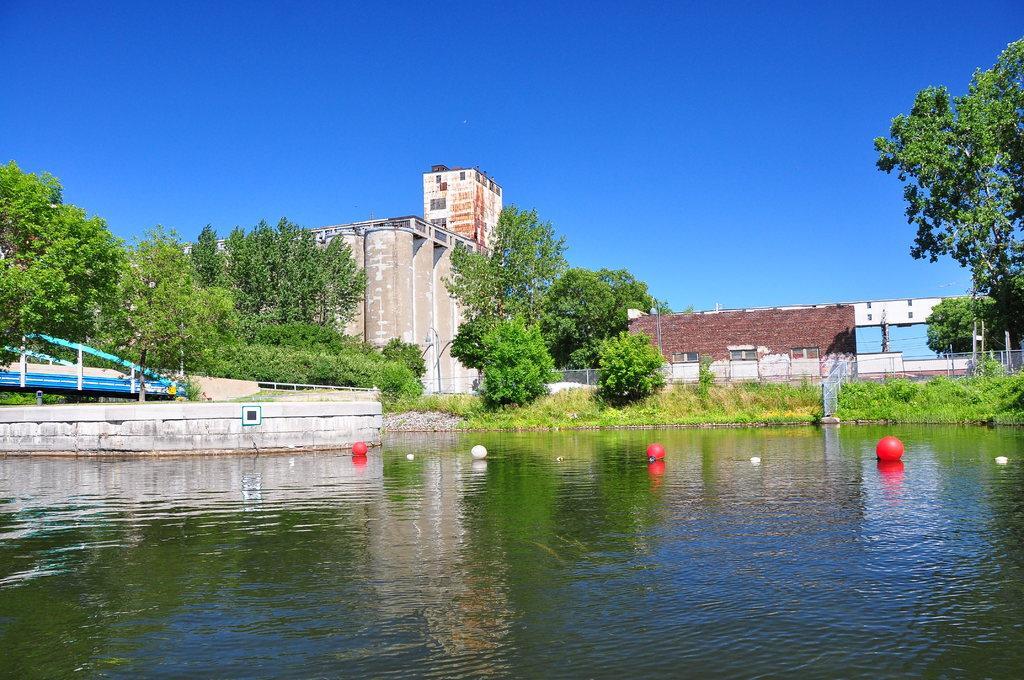Please provide a concise description of this image. In this image I can see the water, in the water I can see few balloons in red and white color. Background I can see trees in green color, buildings in cream and brown color and the sky is in blue color. 